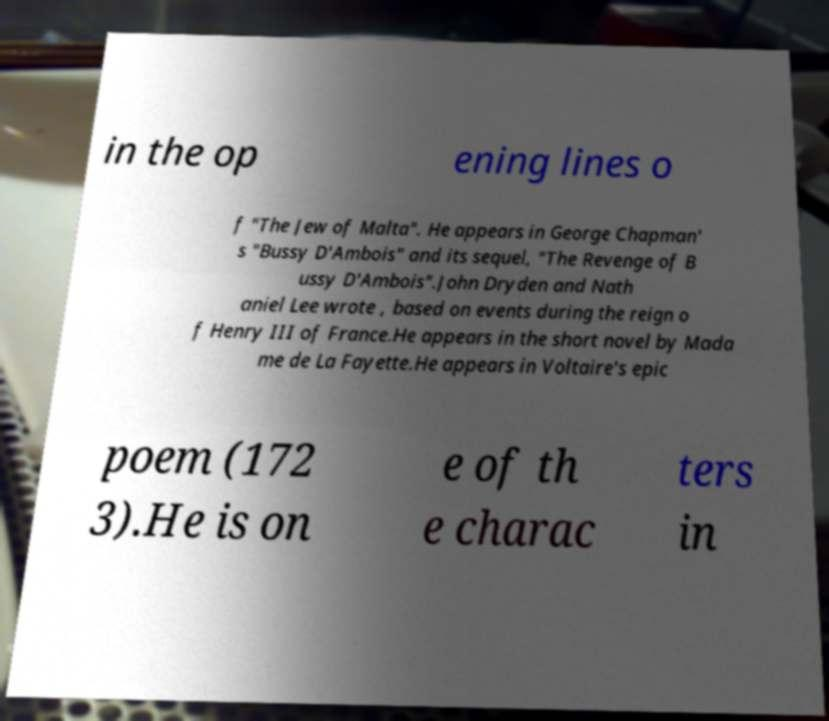There's text embedded in this image that I need extracted. Can you transcribe it verbatim? in the op ening lines o f "The Jew of Malta". He appears in George Chapman' s "Bussy D'Ambois" and its sequel, "The Revenge of B ussy D'Ambois".John Dryden and Nath aniel Lee wrote , based on events during the reign o f Henry III of France.He appears in the short novel by Mada me de La Fayette.He appears in Voltaire's epic poem (172 3).He is on e of th e charac ters in 